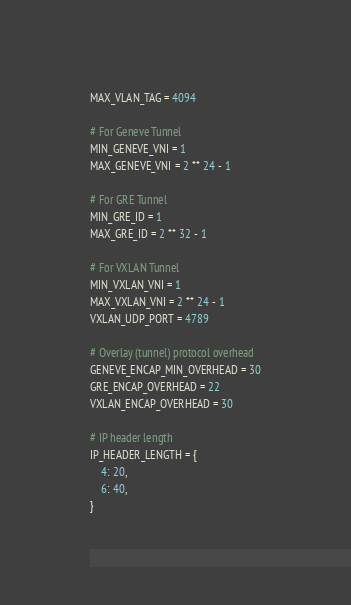<code> <loc_0><loc_0><loc_500><loc_500><_Python_>MAX_VLAN_TAG = 4094

# For Geneve Tunnel
MIN_GENEVE_VNI = 1
MAX_GENEVE_VNI = 2 ** 24 - 1

# For GRE Tunnel
MIN_GRE_ID = 1
MAX_GRE_ID = 2 ** 32 - 1

# For VXLAN Tunnel
MIN_VXLAN_VNI = 1
MAX_VXLAN_VNI = 2 ** 24 - 1
VXLAN_UDP_PORT = 4789

# Overlay (tunnel) protocol overhead
GENEVE_ENCAP_MIN_OVERHEAD = 30
GRE_ENCAP_OVERHEAD = 22
VXLAN_ENCAP_OVERHEAD = 30

# IP header length
IP_HEADER_LENGTH = {
    4: 20,
    6: 40,
}
</code> 